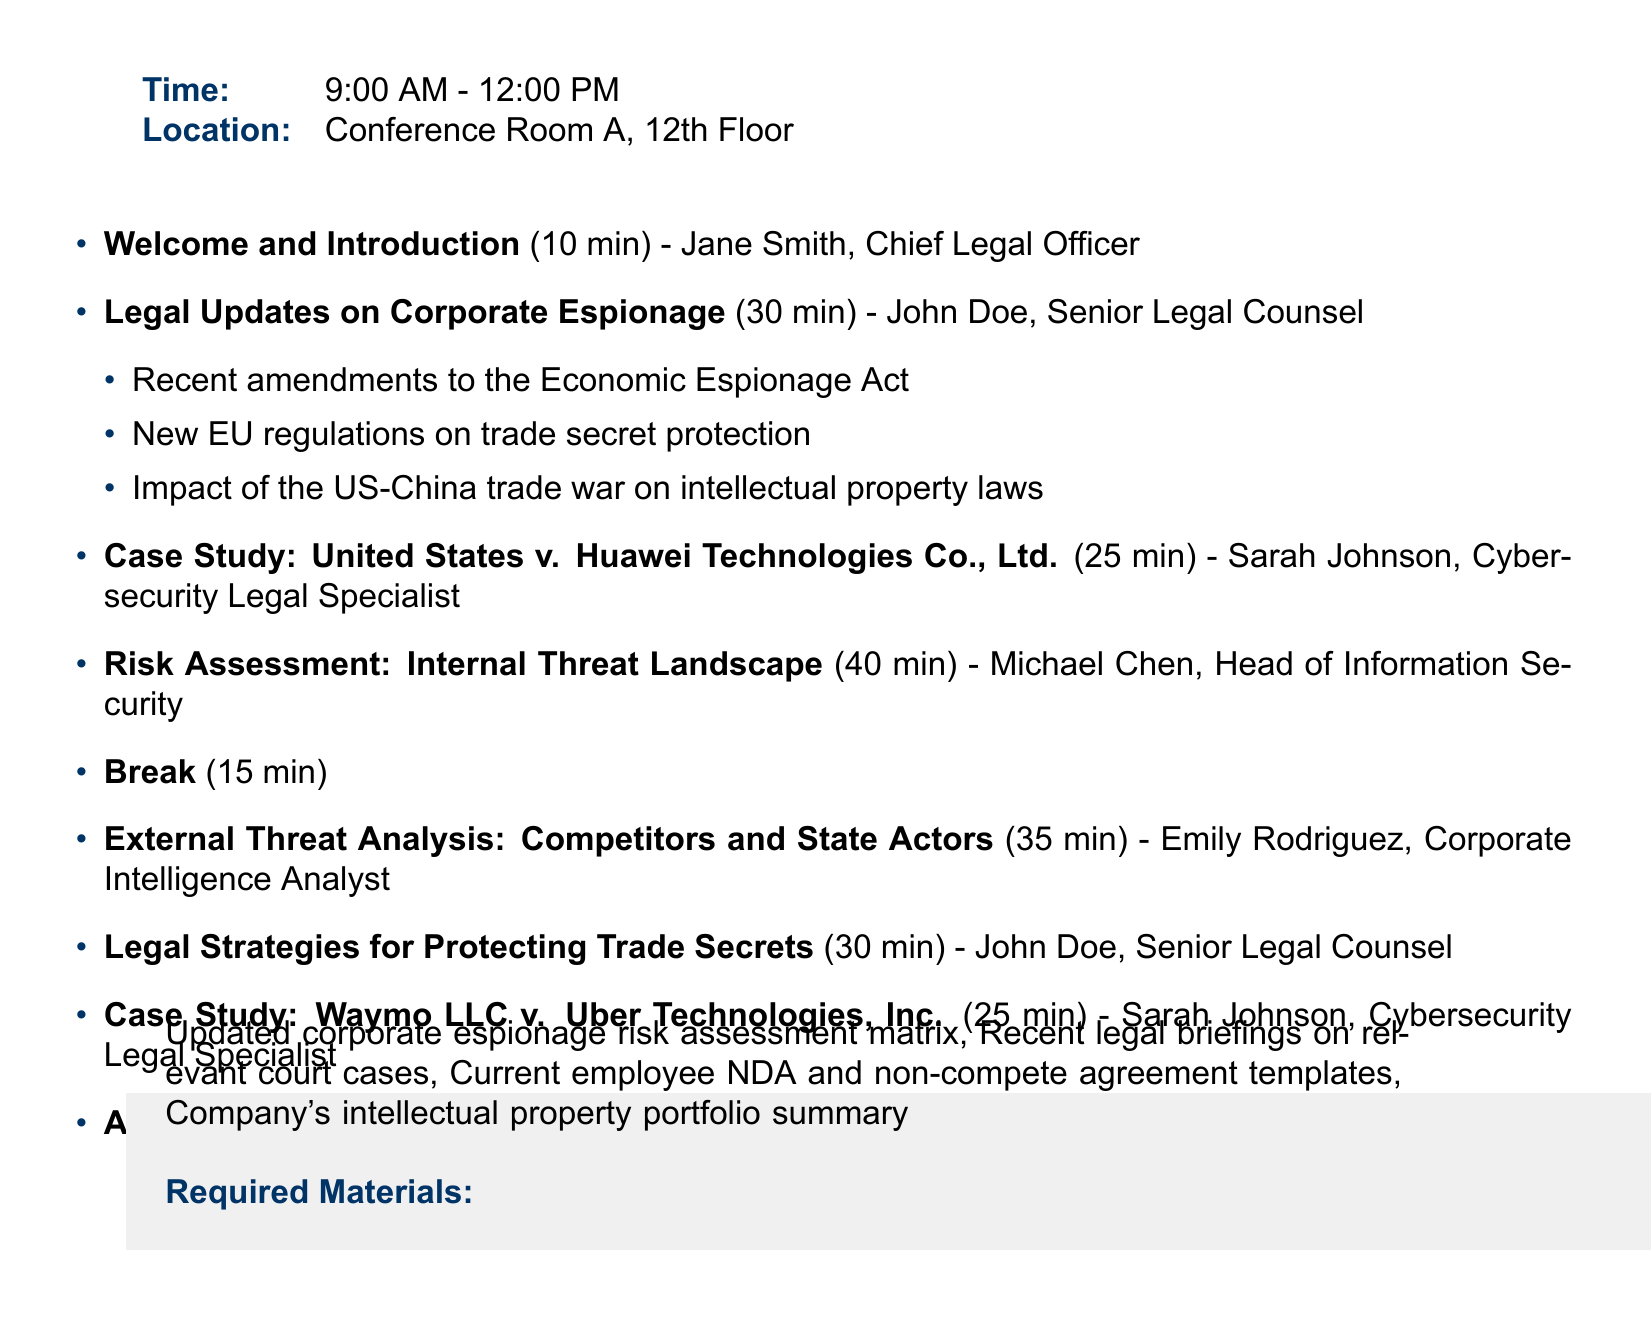What is the date of the meeting? The date of the meeting is explicitly mentioned at the top of the document.
Answer: June 15, 2023 Who is presenting the "Legal Updates on Corporate Espionage"? This information is noted next to the agenda item in the document.
Answer: John Doe, Senior Legal Counsel How long is the "Break" scheduled for? The duration for the Break is clearly stated in the agenda items.
Answer: 15 minutes What is one of the subtopics under "Legal Strategies for Protecting Trade Secrets"? The subtopics are listed under the corresponding agenda item, allowing for selection of any of them.
Answer: Non-disclosure agreements and their enforceability How many minutes are allocated for the "Risk Assessment: Internal Threat Landscape"? The duration for this agenda item can be easily found in the meeting schedule.
Answer: 40 minutes What is the last agenda item? The last item in the agenda is identified at the end of the list of agenda items.
Answer: Action Items and Next Steps Which company is involved in the first case study presented? The name of the company is included in the title of the case study section.
Answer: Huawei Technologies Co., Ltd What section includes required materials? The required materials section is explicitly detailed towards the end of the document.
Answer: Required Materials 